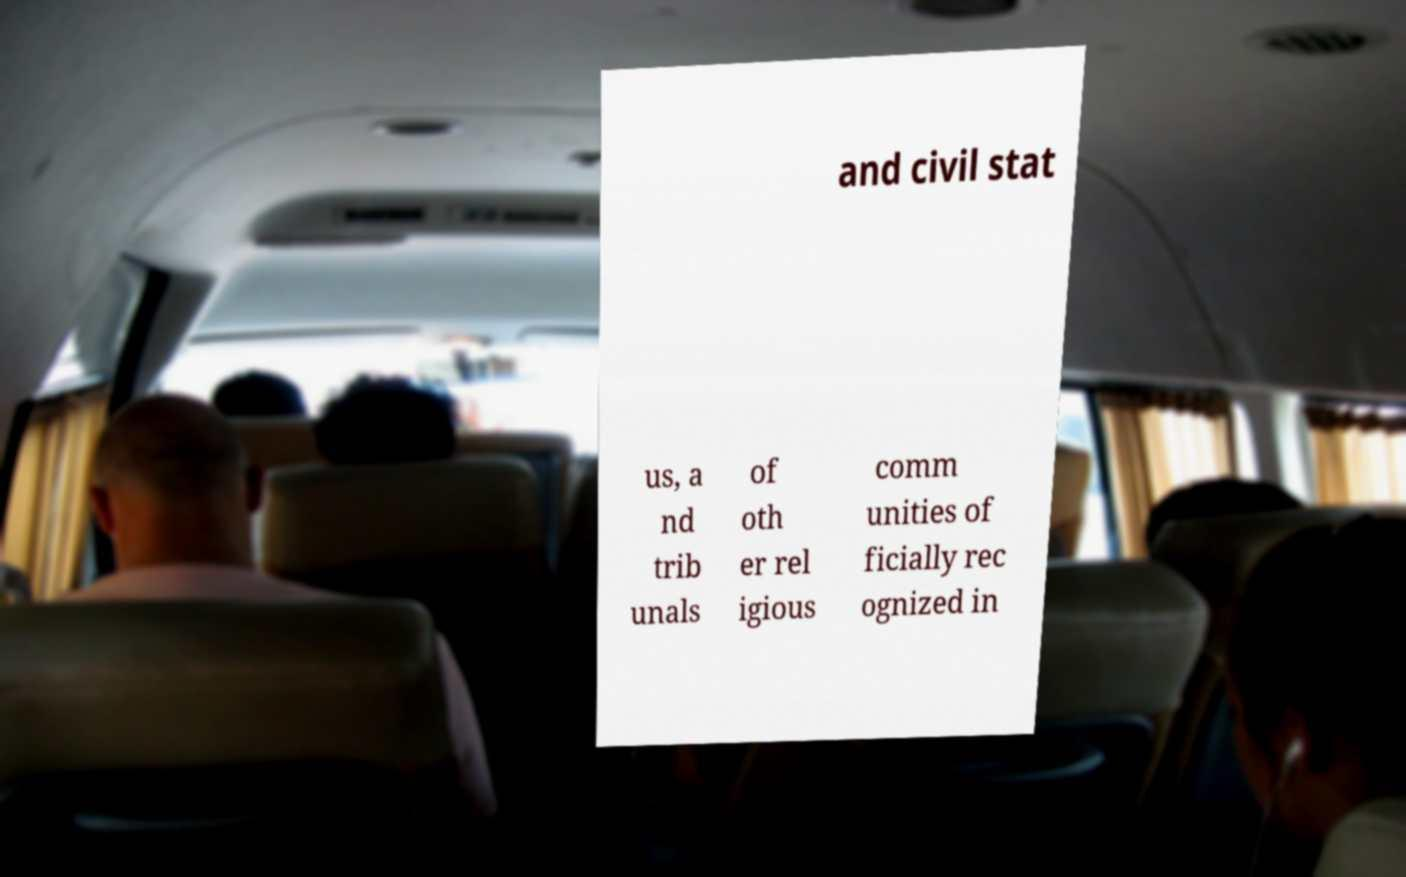There's text embedded in this image that I need extracted. Can you transcribe it verbatim? and civil stat us, a nd trib unals of oth er rel igious comm unities of ficially rec ognized in 